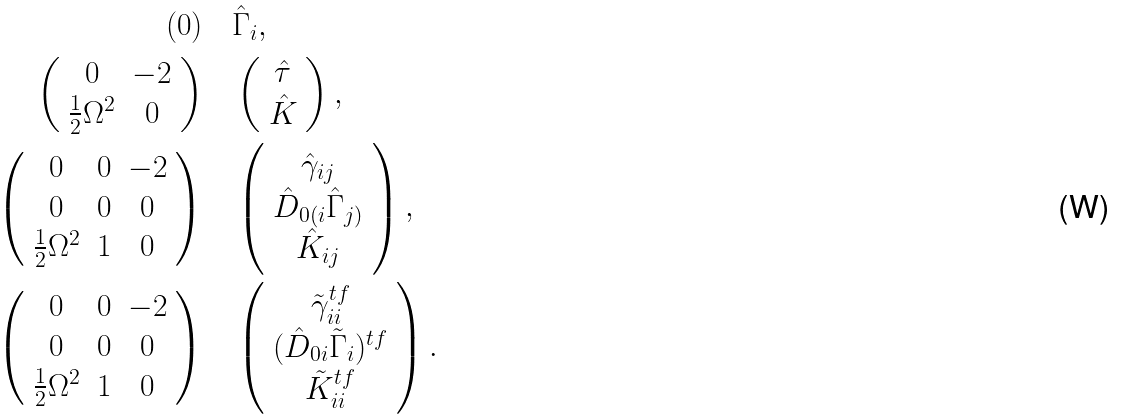Convert formula to latex. <formula><loc_0><loc_0><loc_500><loc_500>( 0 ) & \quad \hat { \Gamma } _ { i } , \\ \left ( \begin{array} { c c } 0 & - 2 \\ \frac { 1 } { 2 } \Omega ^ { 2 } & 0 \end{array} \right ) & \quad \left ( \begin{array} { c } \hat { \tau } \\ \hat { K } \end{array} \right ) , \\ \left ( \begin{array} { c c c } 0 & 0 & - 2 \\ 0 & 0 & 0 \\ \frac { 1 } { 2 } \Omega ^ { 2 } & 1 & 0 \end{array} \right ) & \quad \left ( \begin{array} { c } \hat { \gamma } _ { i j } \\ \hat { D } _ { 0 ( i } \hat { \Gamma } _ { j ) } \\ \hat { K } _ { i j } \end{array} \right ) , \\ \left ( \begin{array} { c c c } 0 & 0 & - 2 \\ 0 & 0 & 0 \\ \frac { 1 } { 2 } \Omega ^ { 2 } & 1 & 0 \end{array} \right ) & \quad \left ( \begin{array} { c } \tilde { \gamma } _ { i i } ^ { t f } \\ ( \hat { D } _ { 0 i } \tilde { \Gamma } _ { i } ) ^ { t f } \\ \tilde { K } _ { i i } ^ { t f } \end{array} \right ) .</formula> 